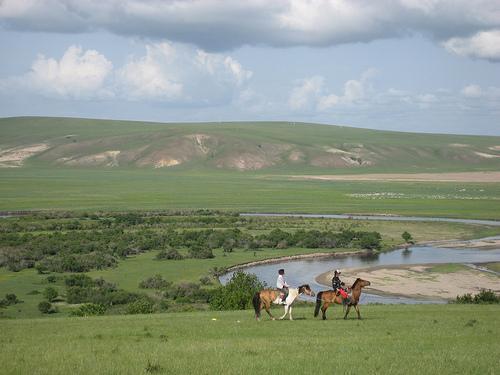What word would best describe their movement?
Answer the question by selecting the correct answer among the 4 following choices.
Options: Gallop, skip, walk, sprint. Walk. 